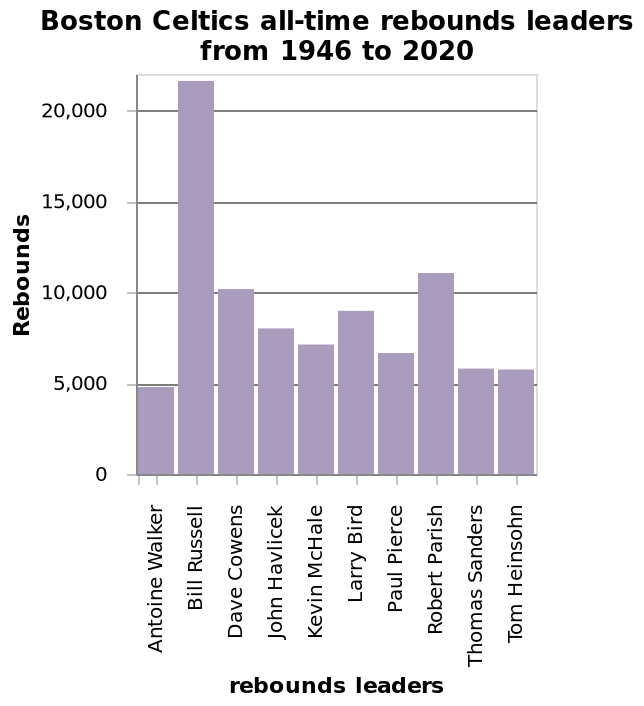<image>
Is there a discernible trend or pattern in the rebounding numbers? No, there is no discernible trend or pattern in the rebounding numbers. 